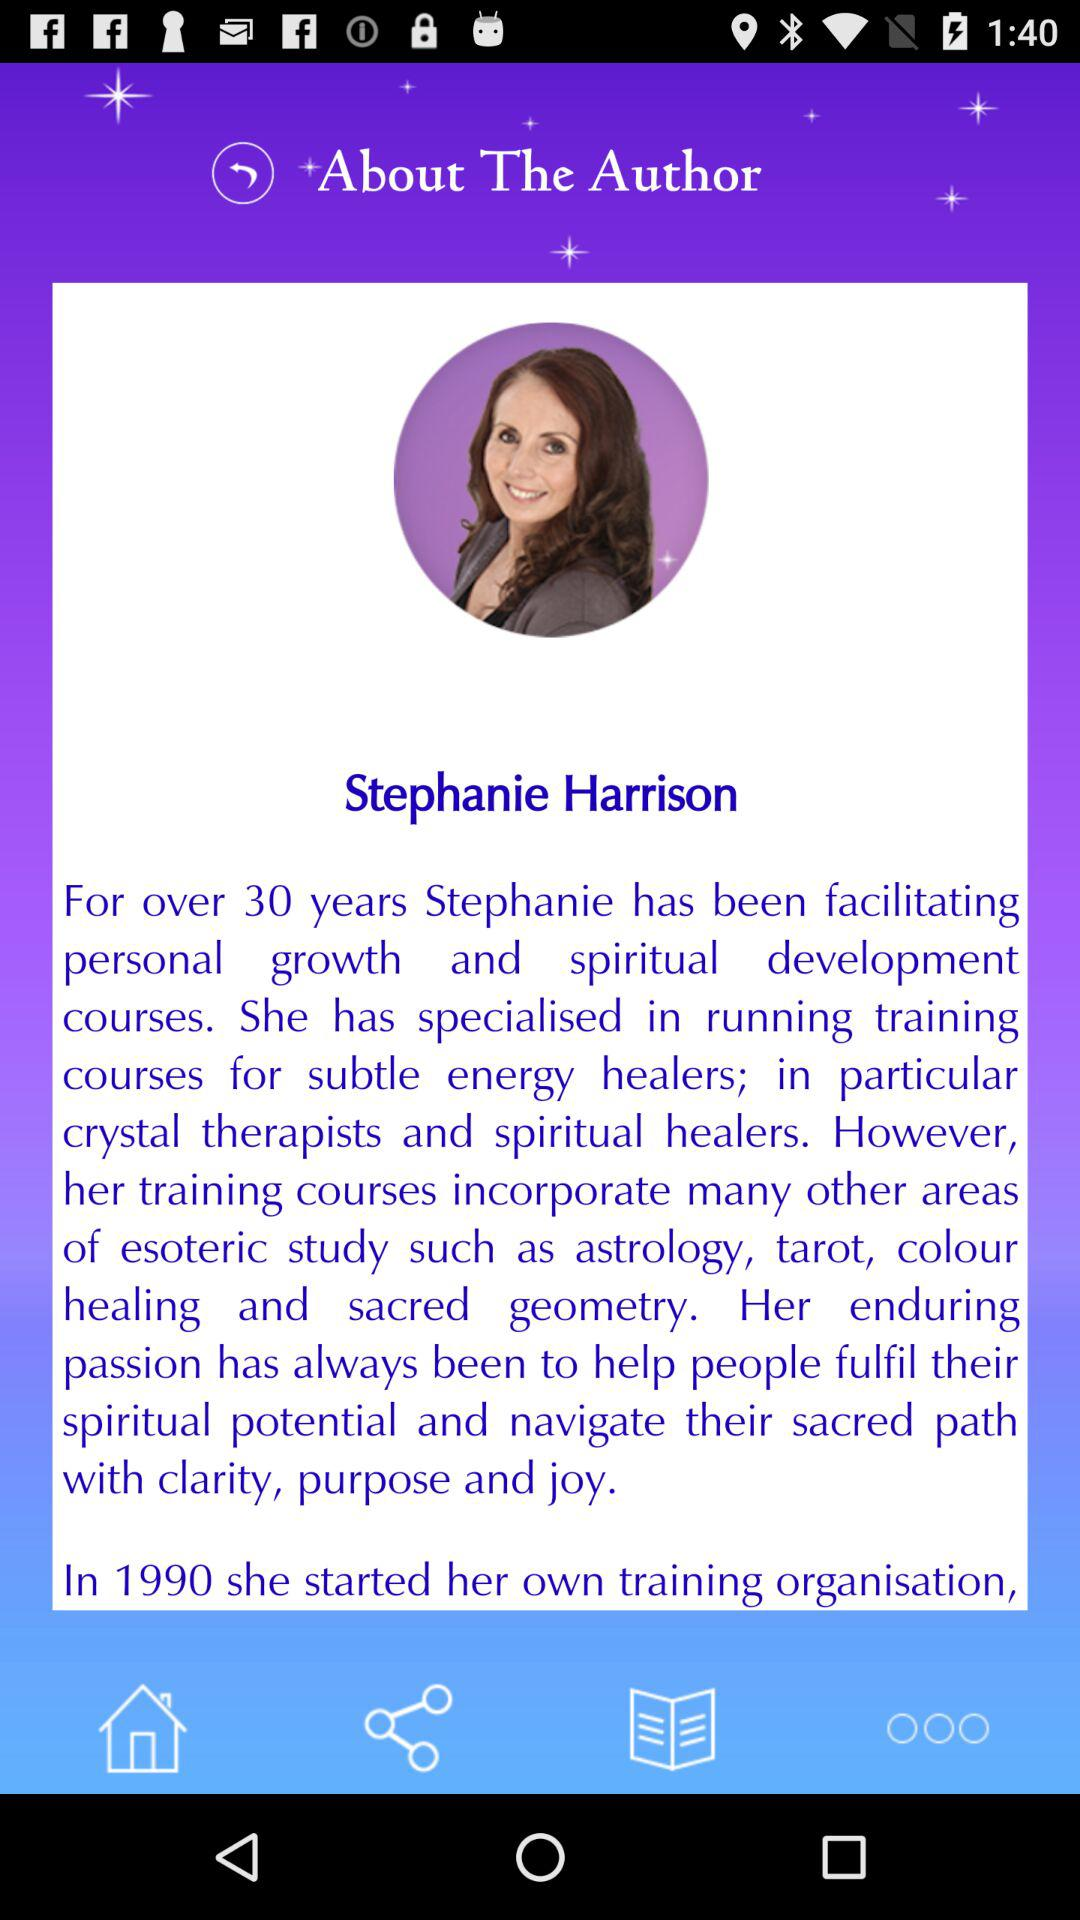What is the author's name? The author's name is Stephanie Harrison. 